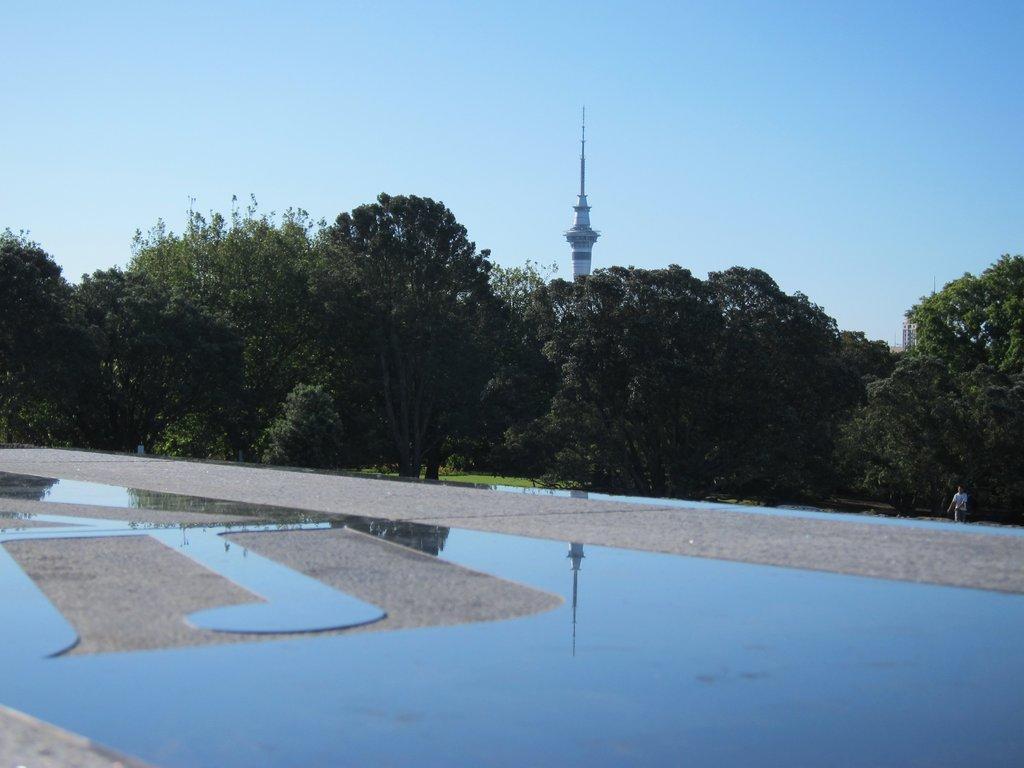Please provide a concise description of this image. At the bottom of the picture, we see the road. The man in the white T-shirt is walking in the garden. Behind him, there are many trees. There is a tower in the background. At the top of the picture, we see the sky. 